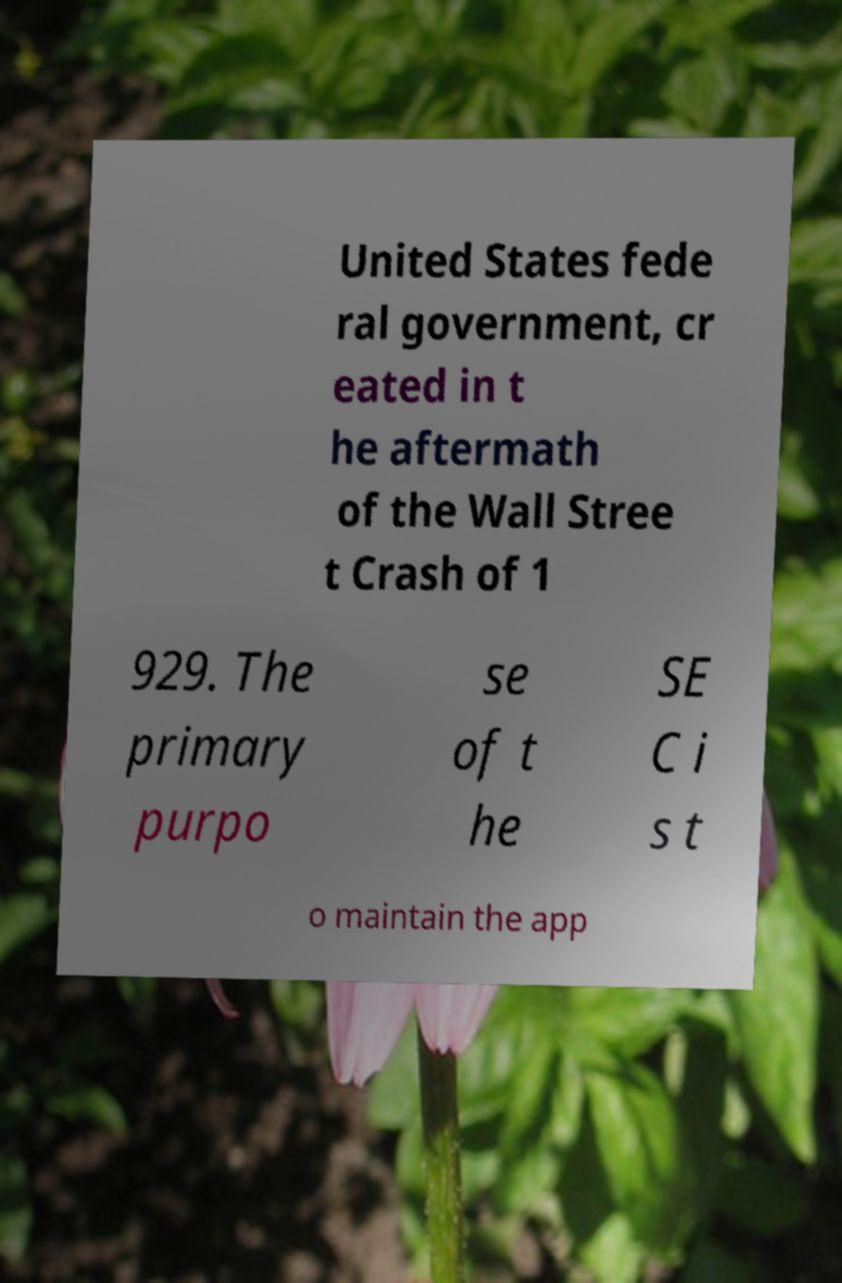For documentation purposes, I need the text within this image transcribed. Could you provide that? United States fede ral government, cr eated in t he aftermath of the Wall Stree t Crash of 1 929. The primary purpo se of t he SE C i s t o maintain the app 